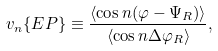Convert formula to latex. <formula><loc_0><loc_0><loc_500><loc_500>v _ { n } \{ E P \} \equiv \frac { \langle \cos n ( \varphi - \Psi _ { R } ) \rangle } { \langle \cos n \Delta \varphi _ { R } \rangle } ,</formula> 